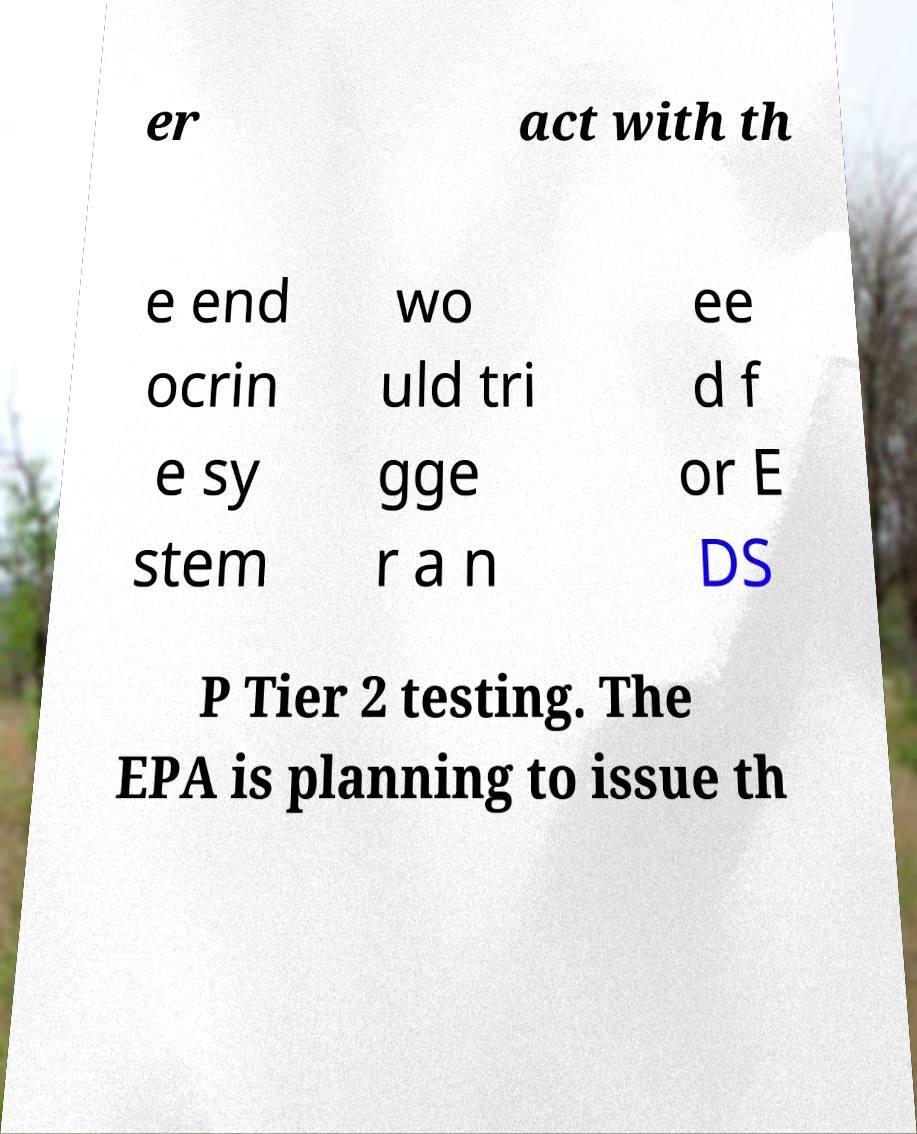There's text embedded in this image that I need extracted. Can you transcribe it verbatim? er act with th e end ocrin e sy stem wo uld tri gge r a n ee d f or E DS P Tier 2 testing. The EPA is planning to issue th 